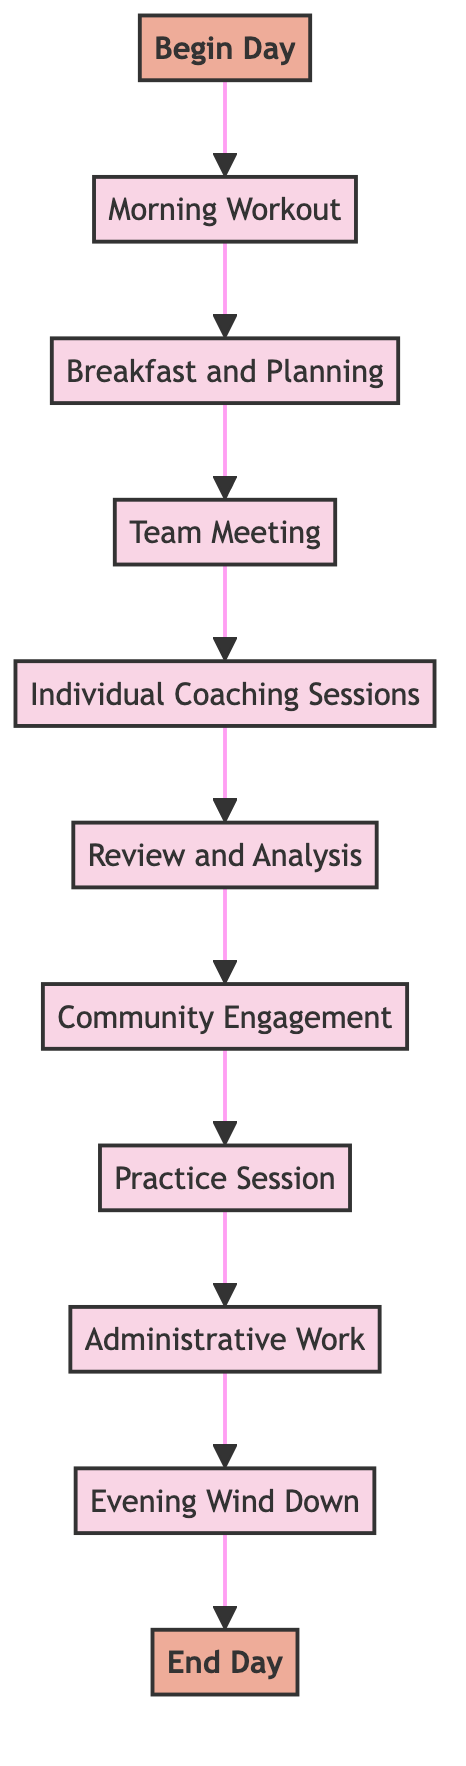What activity comes after Morning Workout? The diagram shows the flow from "Morning Workout" to "Breakfast and Planning." This means the next activity that follows is "Breakfast and Planning."
Answer: Breakfast and Planning How many activities are listed in the diagram? By counting each labeled activity in the diagram, we see that there are a total of nine activities including "Morning Workout," "Breakfast and Planning," "Team Meeting," "Individual Coaching Sessions," "Review and Analysis," "Community Engagement," "Practice Session," "Administrative Work," and "Evening Wind Down."
Answer: Nine What is the last activity before ending the day? Moving through the flow of the diagram, the last activity that occurs before reaching the end is "Evening Wind Down."
Answer: Evening Wind Down Which activities involve direct interaction with players? From analyzing the diagram, the activities "Individual Coaching Sessions" and "Practice Session" are the two that involve direct interaction with players.
Answer: Individual Coaching Sessions and Practice Session What is the first activity listed in the daily routine? Starting from the beginning of the flow, the first activity that appears in the diagram is "Morning Workout."
Answer: Morning Workout What is the purpose of "Review and Analysis"? In the diagram, "Review and Analysis" is described as analyzing game footage and performance data to make informed decisions. Therefore, its purpose is to review game-related information for decision-making.
Answer: Analyze game footage and performance data How do "Team Meeting" and "Practice Session" connect in terms of the coach’s daily tasks? The diagram indicates a sequential flow where after "Team Meeting," the next step is "Individual Coaching Sessions," and following that is "Practice Session." Therefore, they are connected as consecutive activities within the daily routine.
Answer: Sequential activities Which activity includes community involvement? The activity labeled "Community Engagement" explicitly mentions engaging with the local community, making it the activity that includes community involvement.
Answer: Community Engagement What activity directly follows "Administrative Work"? According to the flow of the diagram, "Evening Wind Down" directly follows "Administrative Work." This relationship indicates that administrative tasks finish before relaxation begins.
Answer: Evening Wind Down 